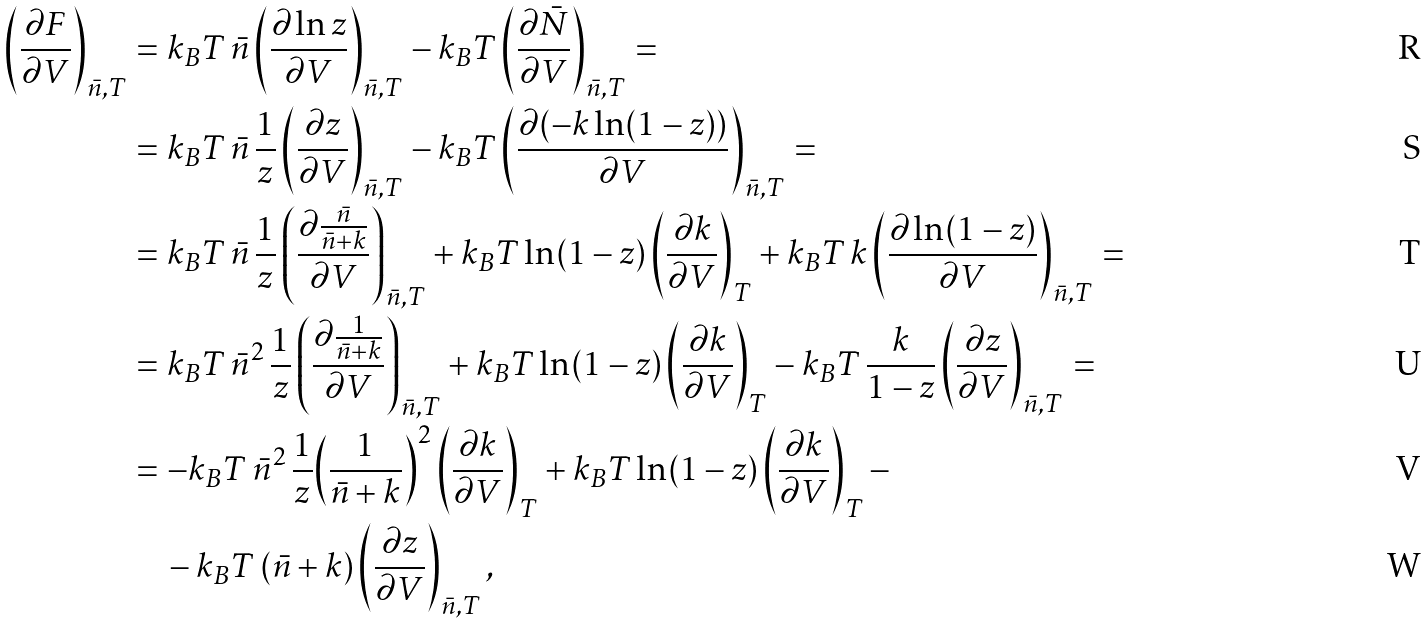<formula> <loc_0><loc_0><loc_500><loc_500>\left ( \frac { \partial F } { \partial V } \right ) _ { \bar { n } , T } & = k _ { B } T \, \bar { n } \left ( \frac { \partial \ln z } { \partial V } \right ) _ { \bar { n } , T } - k _ { B } T \left ( \frac { \partial \bar { N } } { \partial V } \right ) _ { \bar { n } , T } = \\ & = k _ { B } T \, \bar { n } \, \frac { 1 } { z } \left ( \frac { \partial z } { \partial V } \right ) _ { \bar { n } , T } - k _ { B } T \left ( \frac { \partial ( - k \ln ( 1 - z ) ) } { \partial V } \right ) _ { \bar { n } , T } = \\ & = k _ { B } T \, \bar { n } \, \frac { 1 } { z } \left ( \frac { \partial \frac { \bar { n } } { \bar { n } + k } } { \partial V } \right ) _ { \bar { n } , T } + k _ { B } T \ln ( 1 - z ) \left ( \frac { \partial k } { \partial V } \right ) _ { T } + k _ { B } T \, k \left ( \frac { \partial \ln ( 1 - z ) } { \partial V } \right ) _ { \bar { n } , T } = \\ & = k _ { B } T \, \bar { n } ^ { 2 } \, \frac { 1 } { z } \left ( \frac { \partial \frac { 1 } { \bar { n } + k } } { \partial V } \right ) _ { \bar { n } , T } + k _ { B } T \ln ( 1 - z ) \left ( \frac { \partial k } { \partial V } \right ) _ { T } - k _ { B } T \, \frac { k } { 1 - z } \left ( \frac { \partial z } { \partial V } \right ) _ { \bar { n } , T } = \\ & = - k _ { B } T \, \bar { n } ^ { 2 } \, \frac { 1 } { z } { \left ( \frac { 1 } { \bar { n } + k } \right ) } ^ { 2 } \left ( \frac { \partial k } { \partial V } \right ) _ { T } + k _ { B } T \ln ( 1 - z ) \left ( \frac { \partial k } { \partial V } \right ) _ { T } - \\ & \quad - k _ { B } T \, ( \bar { n } + k ) \left ( \frac { \partial z } { \partial V } \right ) _ { \bar { n } , T } ,</formula> 